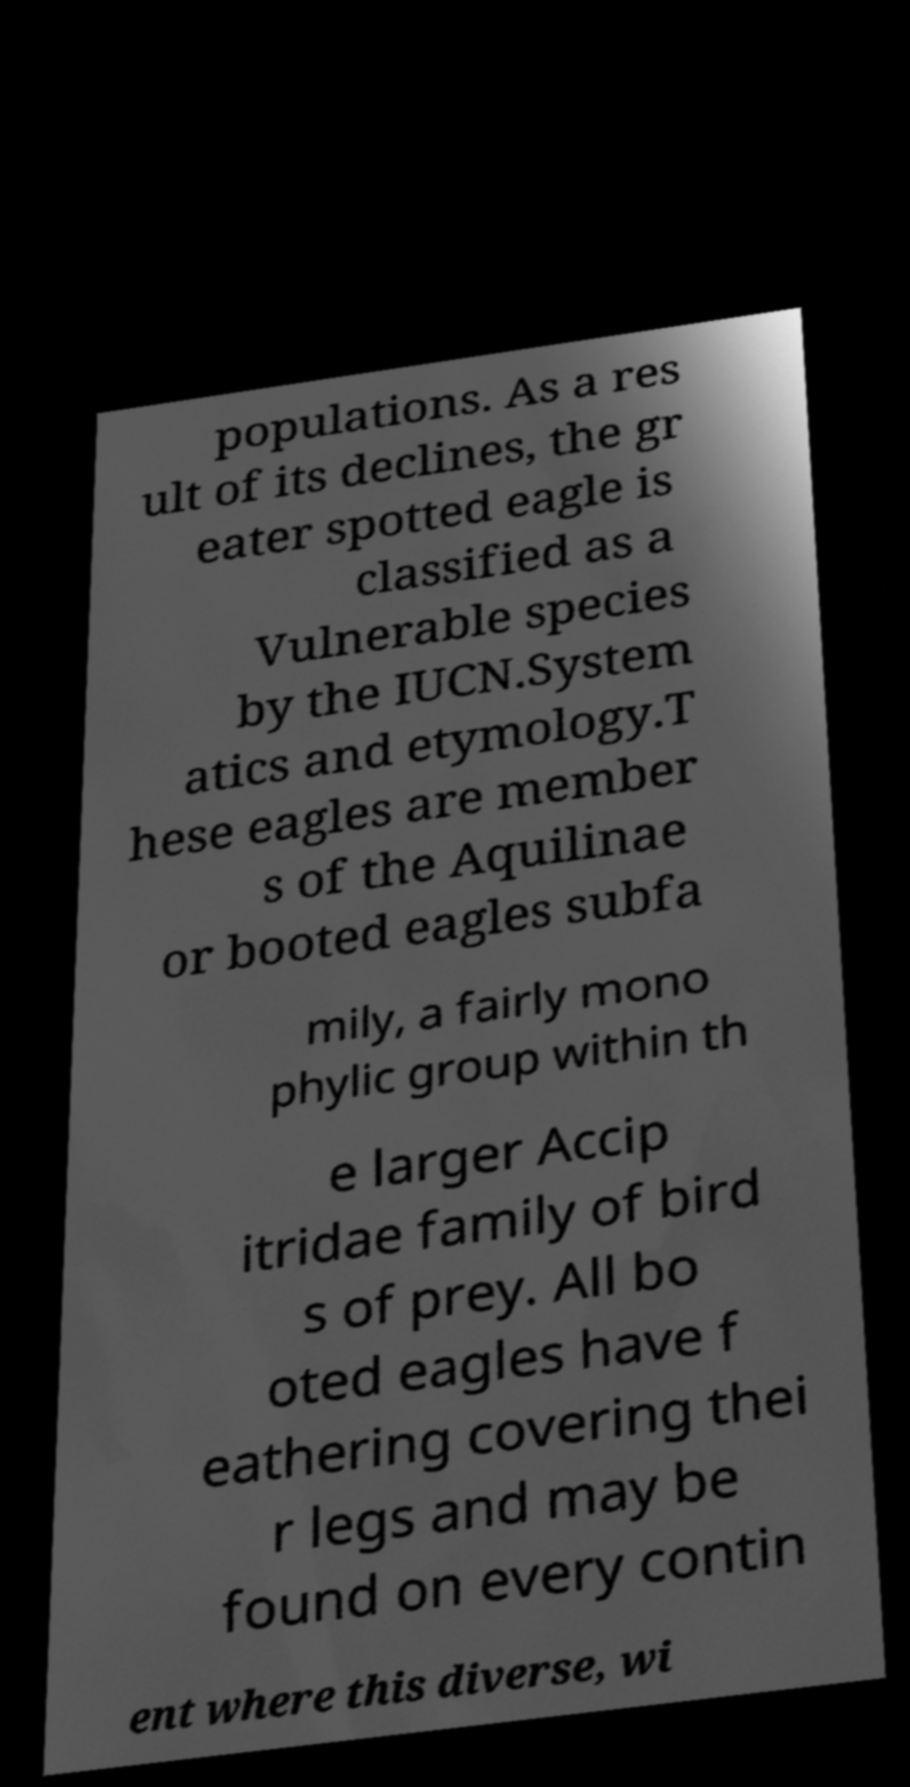Can you accurately transcribe the text from the provided image for me? populations. As a res ult of its declines, the gr eater spotted eagle is classified as a Vulnerable species by the IUCN.System atics and etymology.T hese eagles are member s of the Aquilinae or booted eagles subfa mily, a fairly mono phylic group within th e larger Accip itridae family of bird s of prey. All bo oted eagles have f eathering covering thei r legs and may be found on every contin ent where this diverse, wi 